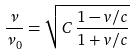Convert formula to latex. <formula><loc_0><loc_0><loc_500><loc_500>\frac { \nu } { \nu _ { 0 } } = \sqrt { C \, \frac { 1 - v / c } { 1 + v / c } }</formula> 